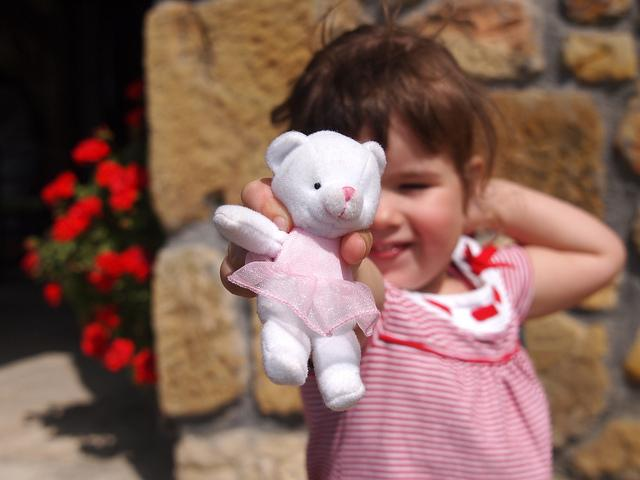What is she doing with the stuffed animal? Please explain your reasoning. squeezing it. The little girl is squeezing the animal. 